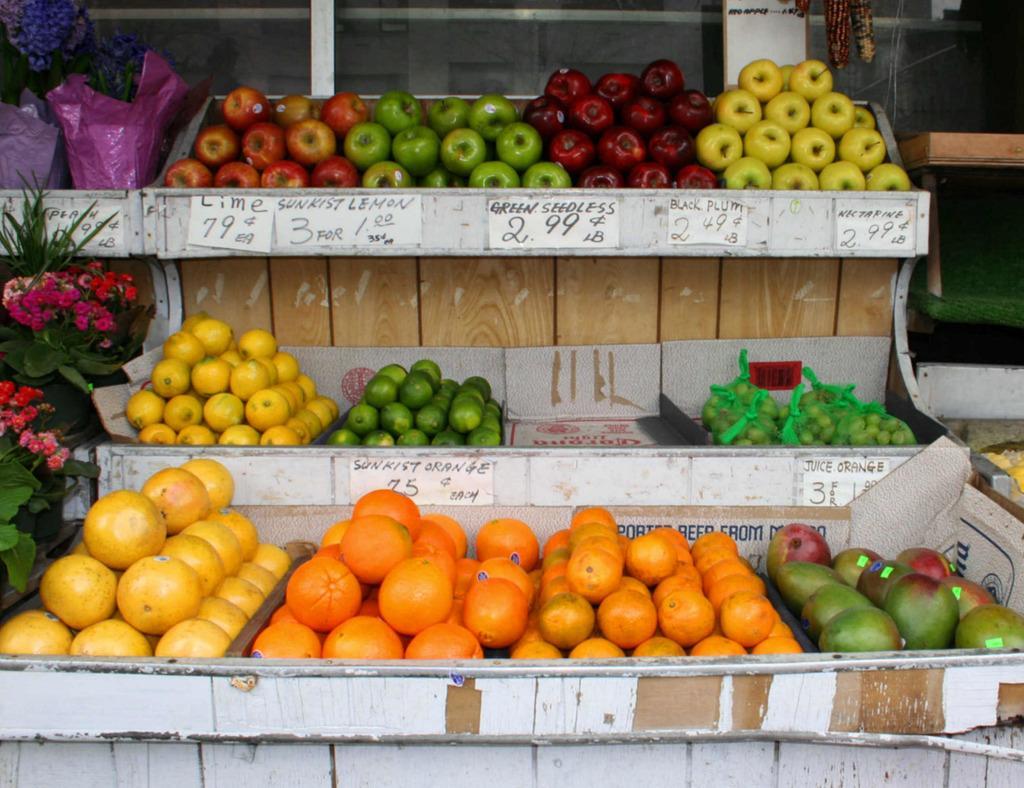How would you summarize this image in a sentence or two? In this picture we can see apples, oranges, fruits and flower bouquets in baskets and we can see objects. 